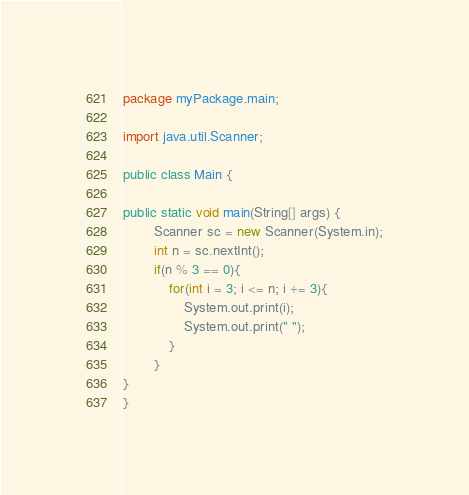Convert code to text. <code><loc_0><loc_0><loc_500><loc_500><_Java_>package myPackage.main;

import java.util.Scanner;

public class Main {

public static void main(String[] args) {
        Scanner sc = new Scanner(System.in);
        int n = sc.nextInt();
        if(n % 3 == 0){
        	for(int i = 3; i <= n; i += 3){
        		System.out.print(i);
        		System.out.print(" ");
        	}
        }
}
}
</code> 